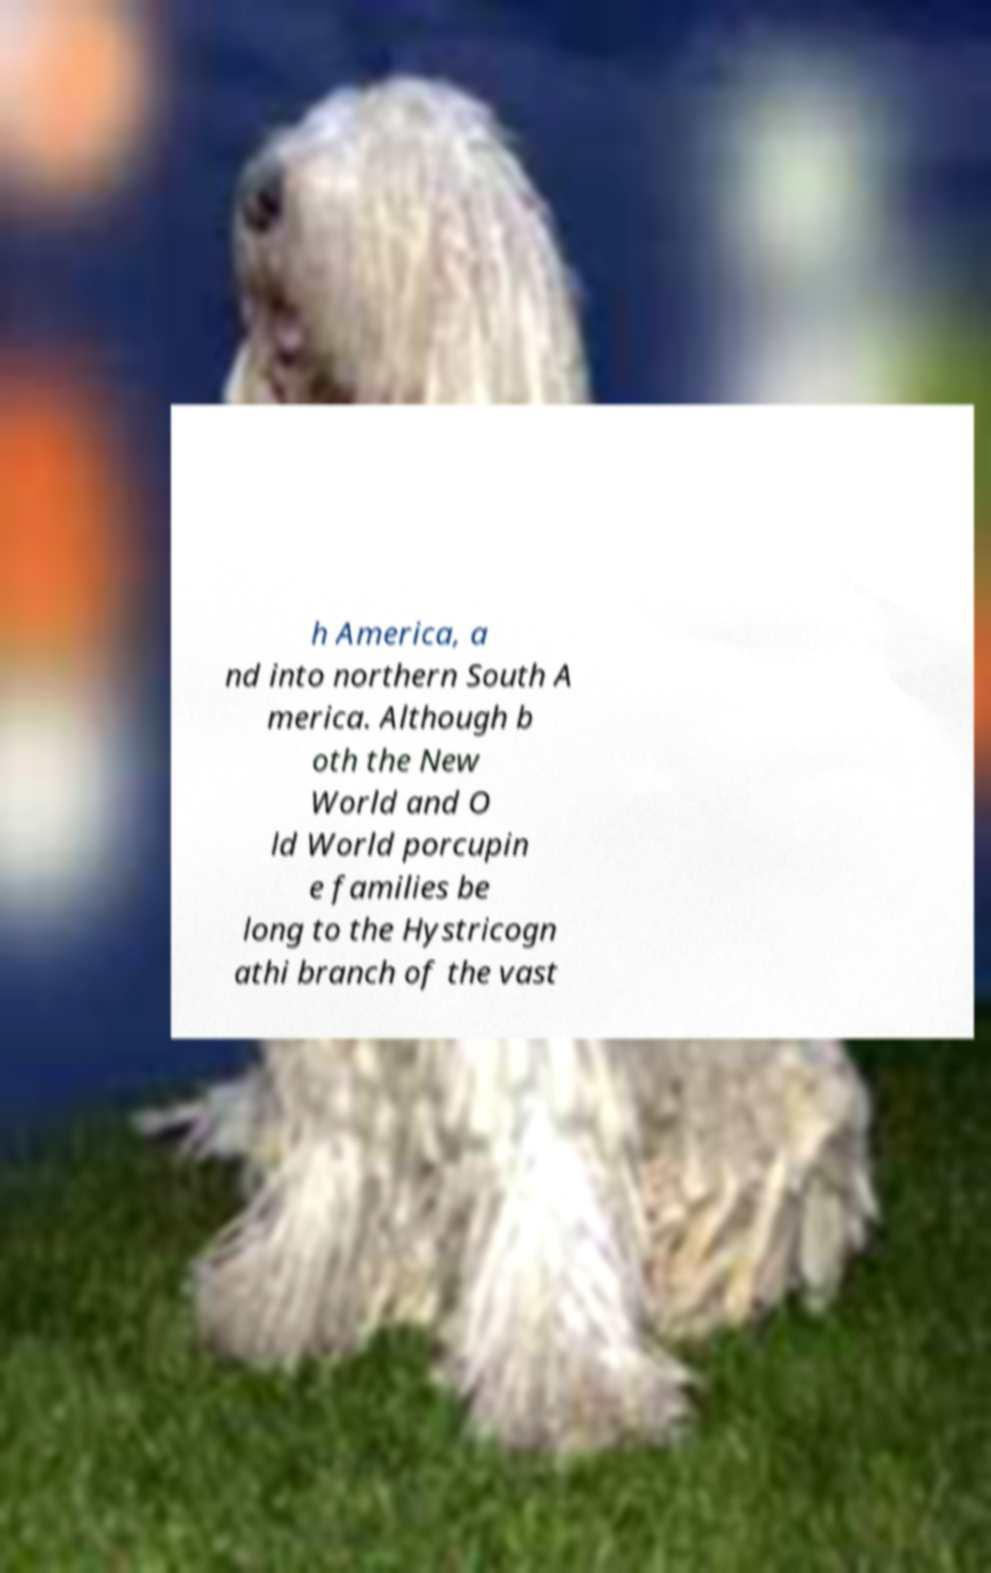I need the written content from this picture converted into text. Can you do that? h America, a nd into northern South A merica. Although b oth the New World and O ld World porcupin e families be long to the Hystricogn athi branch of the vast 